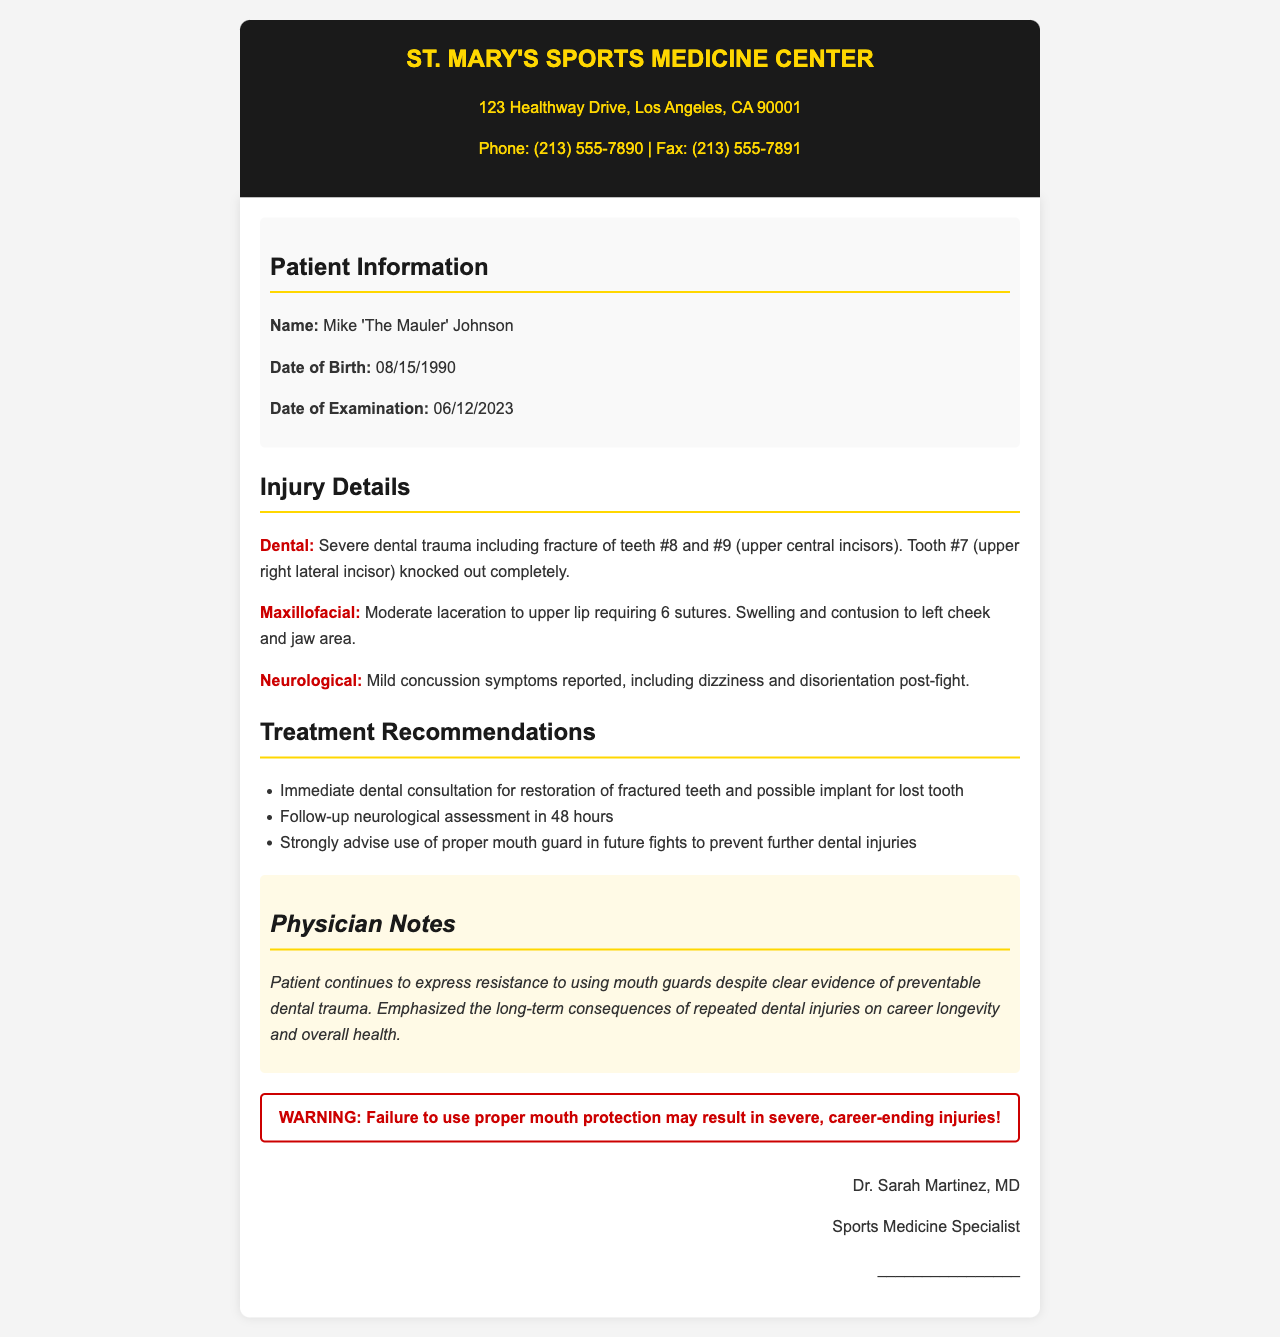what is the name of the patient? The patient's name is clearly stated in the document as Mike 'The Mauler' Johnson.
Answer: Mike 'The Mauler' Johnson when was the examination date? The examination date is provided in the patient information section as 06/12/2023.
Answer: 06/12/2023 how many sutures were required for the upper lip? The document specifies that 6 sutures were required for the moderate laceration on the upper lip.
Answer: 6 what dental injuries were reported? The document outlines the dental injuries as a fracture of teeth #8 and #9, and a complete loss of tooth #7.
Answer: fracture of teeth #8 and #9, tooth #7 knocked out what is the recommendation regarding mouth guards? The treatment recommendations explicitly advise the use of proper mouth guards in future fights to prevent further dental injuries.
Answer: strongly advise use of proper mouth guard what did the physician emphasize about dental injuries? The physician noted the long-term consequences of repeated dental injuries on career longevity and overall health.
Answer: long-term consequences of repeated dental injuries on career longevity and overall health who is the physician that signed the document? The signed document lists Dr. Sarah Martinez, MD, as the medical professional who authored the report.
Answer: Dr. Sarah Martinez, MD what type of professional is Dr. Sarah Martinez? The document describes Dr. Sarah Martinez as a Sports Medicine Specialist.
Answer: Sports Medicine Specialist 